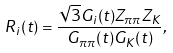<formula> <loc_0><loc_0><loc_500><loc_500>R _ { i } ( t ) = \frac { \sqrt { 3 } G _ { i } ( t ) Z _ { \pi \pi } Z _ { K } } { G _ { \pi \pi } ( t ) G _ { K } ( t ) } ,</formula> 